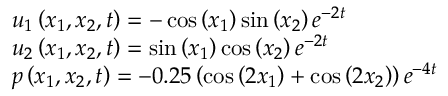Convert formula to latex. <formula><loc_0><loc_0><loc_500><loc_500>\begin{array} { r l } & { u _ { 1 } \left ( x _ { 1 } , x _ { 2 } , t \right ) = - \cos \left ( x _ { 1 } \right ) \sin \left ( x _ { 2 } \right ) { { e } ^ { - 2 t } } } \\ & { u _ { 2 } \left ( x _ { 1 } , x _ { 2 } , t \right ) = \sin \left ( x _ { 1 } \right ) \cos \left ( x _ { 2 } \right ) { { e } ^ { - 2 t } } } \\ & { p \left ( x _ { 1 } , x _ { 2 } , t \right ) = - 0 . 2 5 \left ( \cos \left ( 2 x _ { 1 } \right ) + \cos \left ( 2 x _ { 2 } \right ) \right ) { { e } ^ { - 4 t } } } \end{array}</formula> 